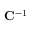Convert formula to latex. <formula><loc_0><loc_0><loc_500><loc_500>C ^ { - 1 }</formula> 